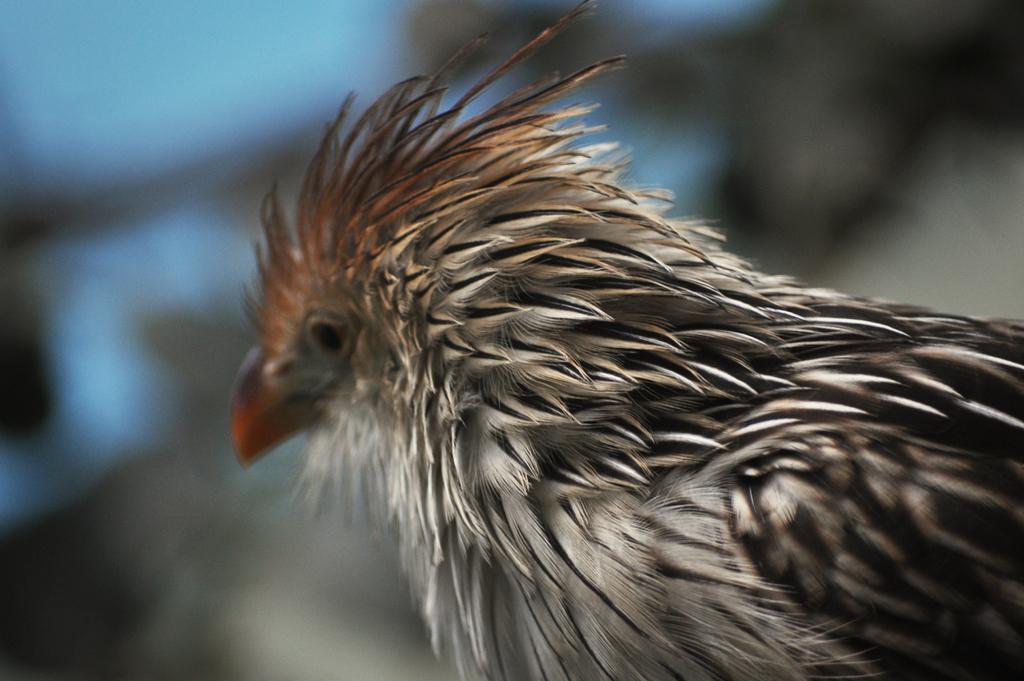Could you give a brief overview of what you see in this image? In this picture I can see a bird. 